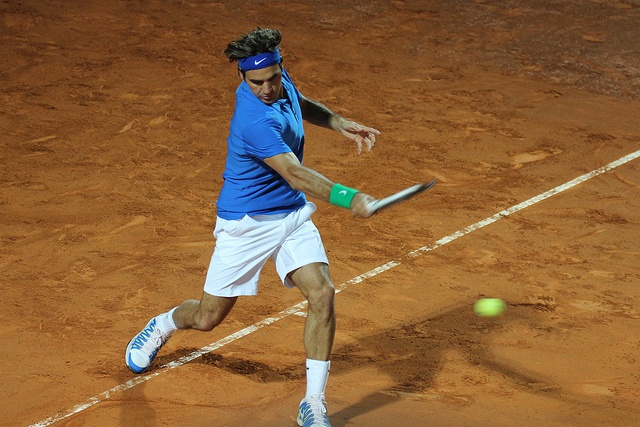Describe the objects in this image and their specific colors. I can see people in maroon, lightblue, blue, gray, and black tones, tennis racket in maroon, lightblue, darkgray, black, and gray tones, and sports ball in maroon, lightgreen, and olive tones in this image. 